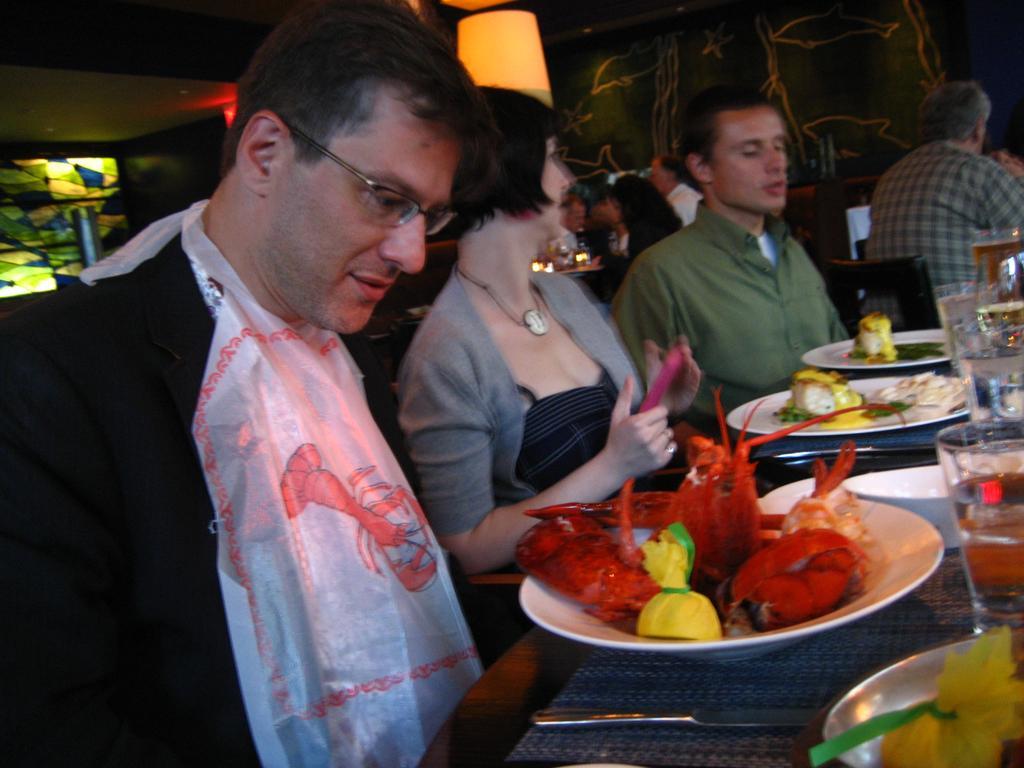Could you give a brief overview of what you see in this image? There are three persons sitting around a table. Person on the left is wearing a specs and is having a cloth tied on the neck. On the cloth there is a design of prawn. And the lady is holding a mobile. On the table there are plates, glasses, knife. On the plate there are food items. In the back there are many people. Also there are lights in the back. 